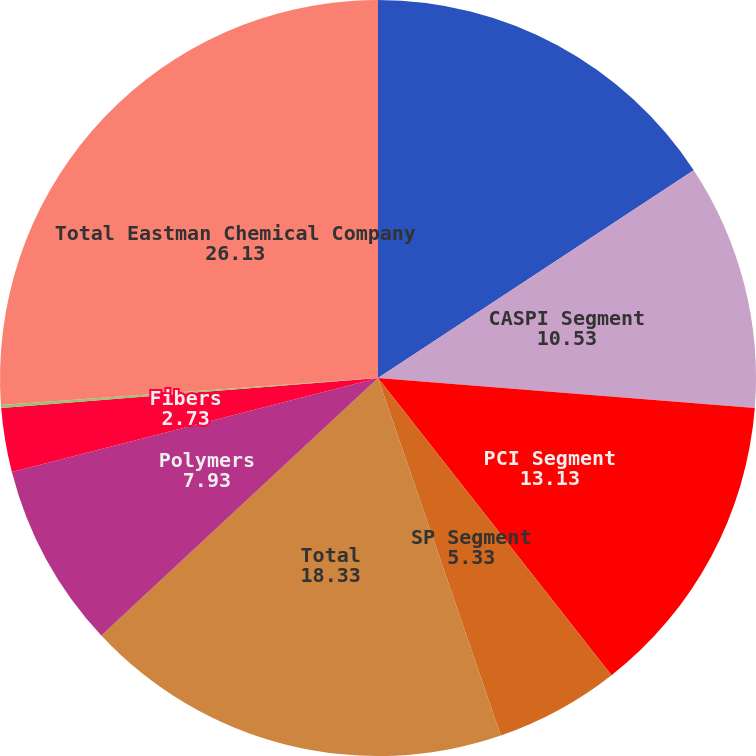Convert chart. <chart><loc_0><loc_0><loc_500><loc_500><pie_chart><fcel>(Dollars in millions)<fcel>CASPI Segment<fcel>PCI Segment<fcel>SP Segment<fcel>Total<fcel>Polymers<fcel>Fibers<fcel>Developing Businesses<fcel>Total Eastman Chemical Company<nl><fcel>15.73%<fcel>10.53%<fcel>13.13%<fcel>5.33%<fcel>18.33%<fcel>7.93%<fcel>2.73%<fcel>0.13%<fcel>26.13%<nl></chart> 